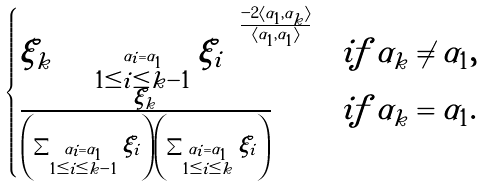<formula> <loc_0><loc_0><loc_500><loc_500>\begin{cases} \xi _ { k } \left ( \sum _ { \stackrel { \alpha _ { i } = \alpha _ { 1 } } { 1 \leq i \leq k - 1 } } \xi _ { i } \right ) ^ { \frac { - 2 \langle \alpha _ { 1 } , \alpha _ { k } \rangle } { \langle \alpha _ { 1 } , \alpha _ { 1 } \rangle } } & i f \, \alpha _ { k } \neq \alpha _ { 1 } , \\ \frac { \xi _ { k } } { \left ( \sum _ { \stackrel { \alpha _ { i } = \alpha _ { 1 } } { 1 \leq i \leq k - 1 } } \xi _ { i } \right ) \left ( \sum _ { \stackrel { \alpha _ { i } = \alpha _ { 1 } } { 1 \leq i \leq k } } \xi _ { i } \right ) } & i f \, \alpha _ { k } = \alpha _ { 1 } . \end{cases}</formula> 